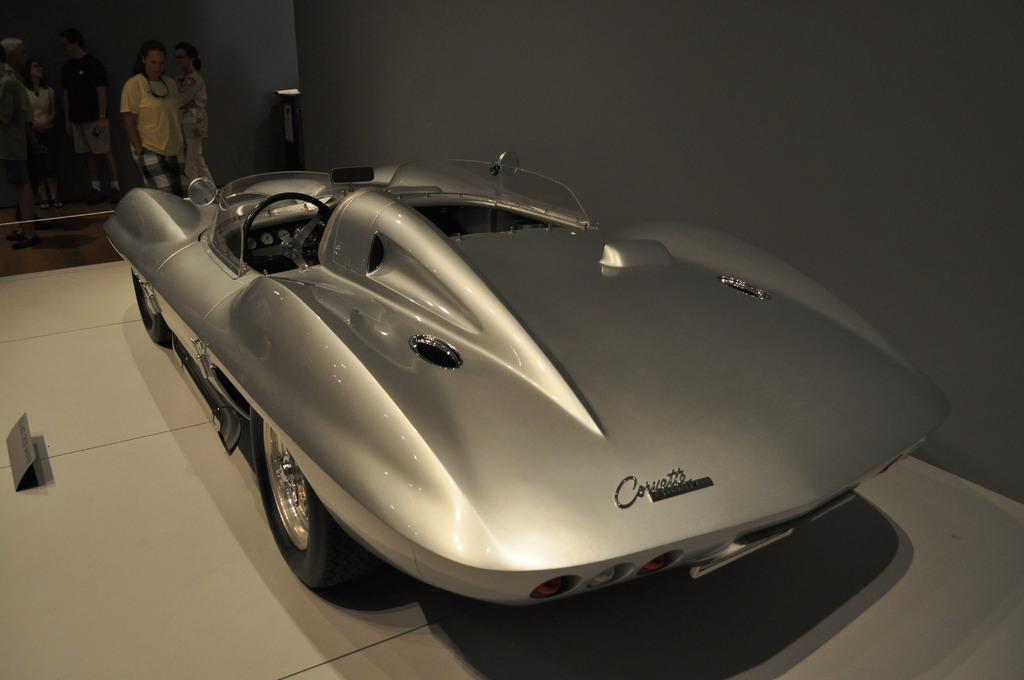What is the main object in the image? There is a car in the image. Where is the car located? The car is on the floor. Can you describe the surroundings in the image? There are people visible in the background of the image. What type of silk fabric is draped over the car in the image? There is no silk fabric present in the image; the car is simply on the floor. 